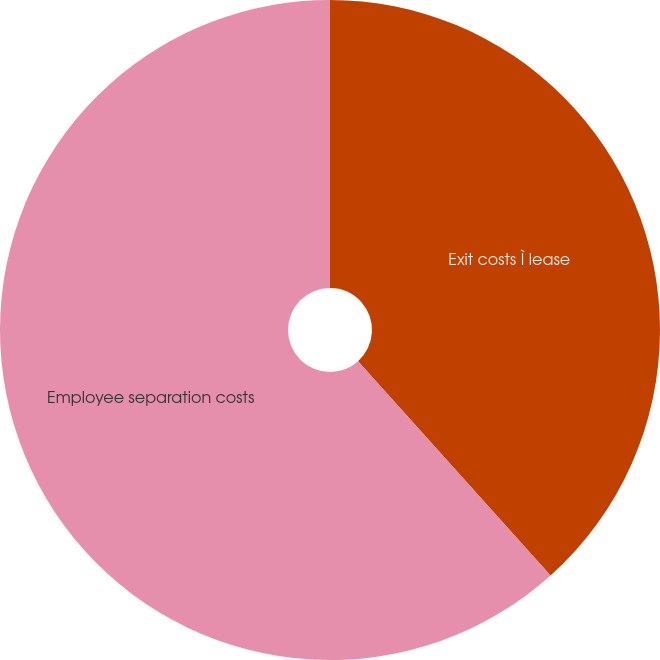Convert chart. <chart><loc_0><loc_0><loc_500><loc_500><pie_chart><fcel>Exit costs Ì lease<fcel>Employee separation costs<nl><fcel>38.35%<fcel>61.65%<nl></chart> 